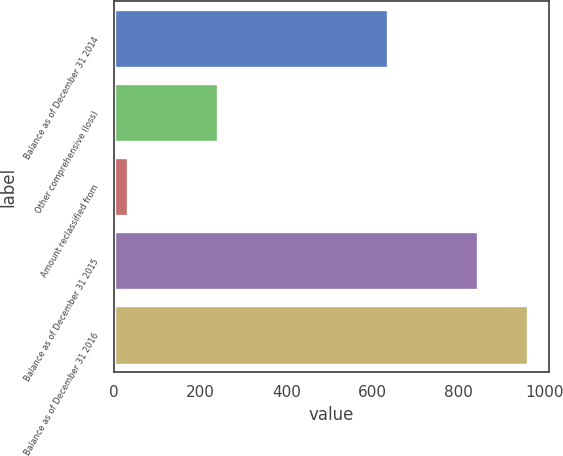Convert chart. <chart><loc_0><loc_0><loc_500><loc_500><bar_chart><fcel>Balance as of December 31 2014<fcel>Other comprehensive (loss)<fcel>Amount reclassified from<fcel>Balance as of December 31 2015<fcel>Balance as of December 31 2016<nl><fcel>636.7<fcel>240.4<fcel>31.5<fcel>845.6<fcel>962.5<nl></chart> 